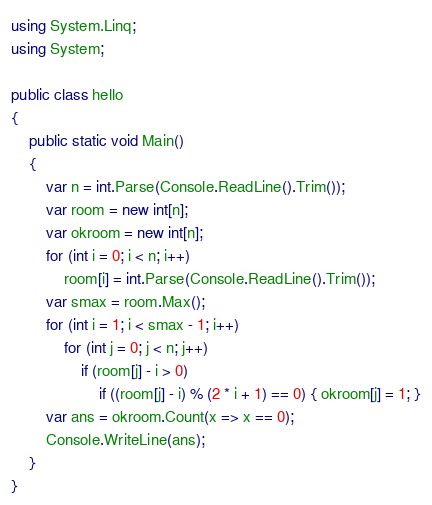Convert code to text. <code><loc_0><loc_0><loc_500><loc_500><_C#_>using System.Linq;
using System;

public class hello
{
    public static void Main()
    {
        var n = int.Parse(Console.ReadLine().Trim());
        var room = new int[n];
        var okroom = new int[n];
        for (int i = 0; i < n; i++)
            room[i] = int.Parse(Console.ReadLine().Trim());
        var smax = room.Max();
        for (int i = 1; i < smax - 1; i++)
            for (int j = 0; j < n; j++)
                if (room[j] - i > 0)
                    if ((room[j] - i) % (2 * i + 1) == 0) { okroom[j] = 1; }
        var ans = okroom.Count(x => x == 0);
        Console.WriteLine(ans);
    }
}</code> 